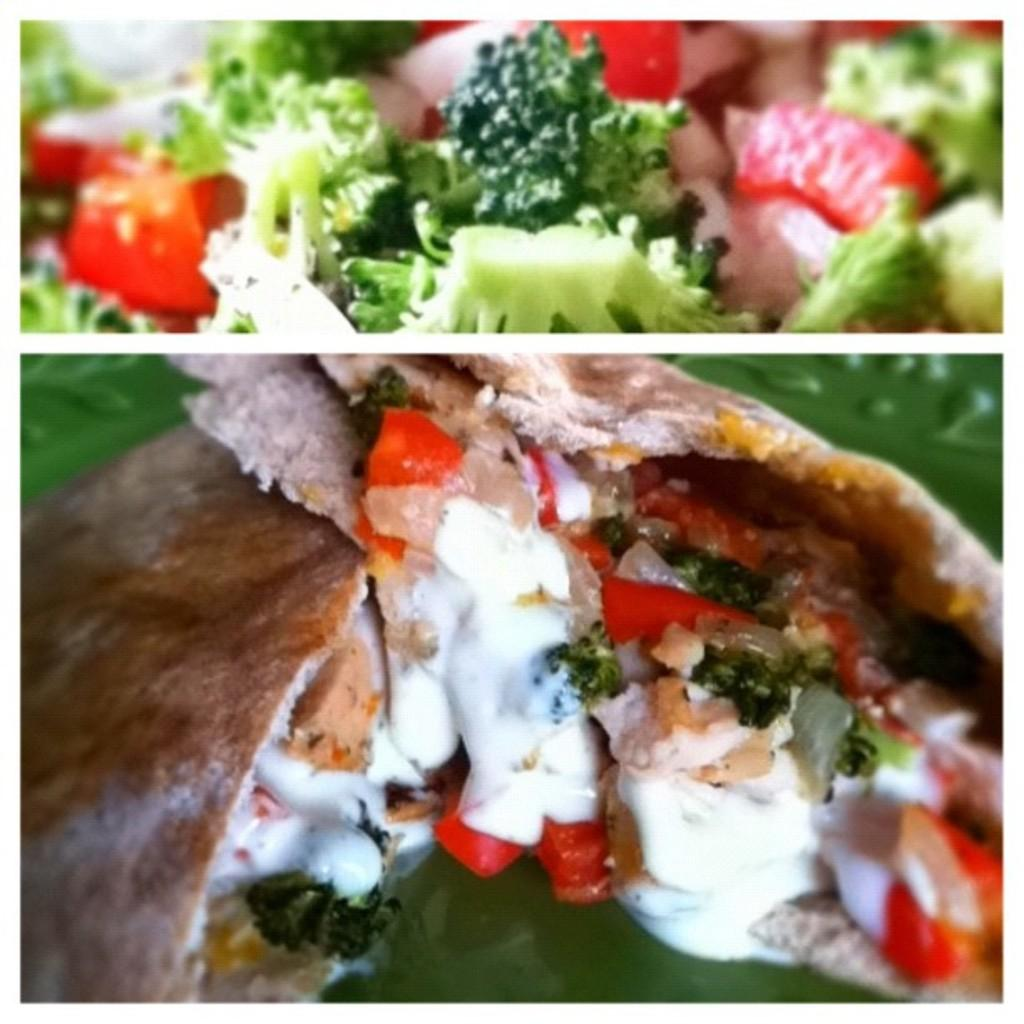How many images are combined in the collage? The image is a collage of two images. What type of subject matter is depicted in the collage? There is food depicted in the collage. What type of houses are shown in the collage? There are no houses depicted in the collage; it features food. Can you provide an example of a government policy related to the food in the collage? There is no information about government policies in the image, as it only shows a collage of food. 